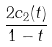Convert formula to latex. <formula><loc_0><loc_0><loc_500><loc_500>\frac { 2 c _ { 2 } ( t ) } { 1 - t }</formula> 